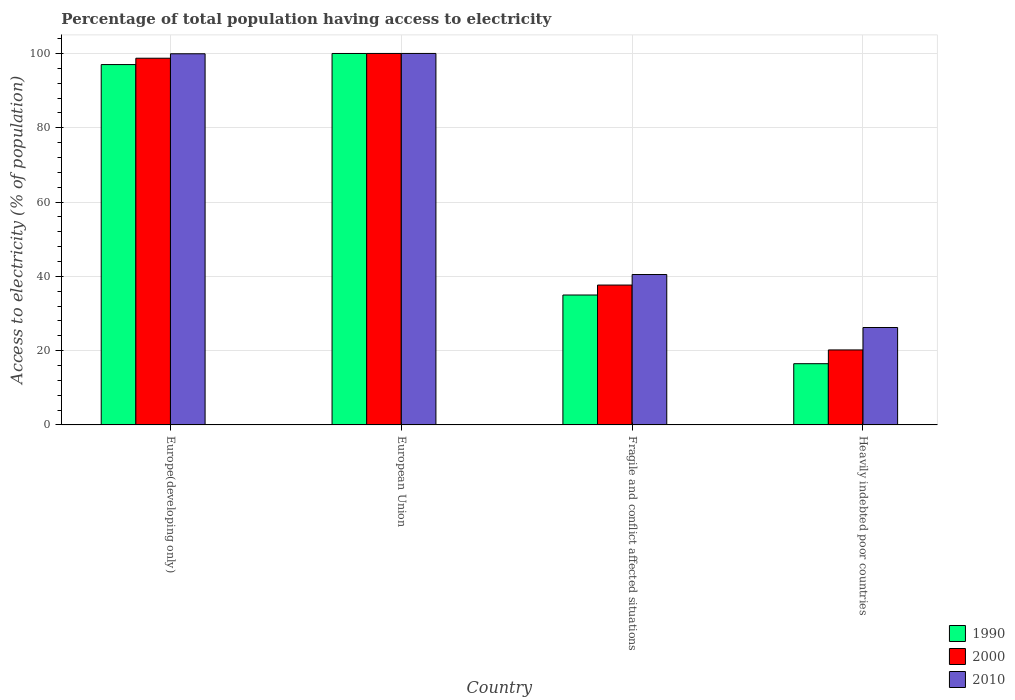How many different coloured bars are there?
Your answer should be very brief. 3. Are the number of bars per tick equal to the number of legend labels?
Your answer should be very brief. Yes. How many bars are there on the 1st tick from the right?
Offer a very short reply. 3. What is the label of the 1st group of bars from the left?
Offer a terse response. Europe(developing only). What is the percentage of population that have access to electricity in 2010 in Fragile and conflict affected situations?
Provide a short and direct response. 40.49. Across all countries, what is the minimum percentage of population that have access to electricity in 1990?
Offer a very short reply. 16.48. In which country was the percentage of population that have access to electricity in 1990 maximum?
Ensure brevity in your answer.  European Union. In which country was the percentage of population that have access to electricity in 2000 minimum?
Your response must be concise. Heavily indebted poor countries. What is the total percentage of population that have access to electricity in 2000 in the graph?
Provide a short and direct response. 256.55. What is the difference between the percentage of population that have access to electricity in 2010 in Europe(developing only) and that in European Union?
Offer a very short reply. -0.09. What is the difference between the percentage of population that have access to electricity in 2000 in Europe(developing only) and the percentage of population that have access to electricity in 1990 in Heavily indebted poor countries?
Provide a succinct answer. 82.24. What is the average percentage of population that have access to electricity in 1990 per country?
Offer a terse response. 62.11. What is the difference between the percentage of population that have access to electricity of/in 2010 and percentage of population that have access to electricity of/in 2000 in European Union?
Provide a short and direct response. 0. What is the ratio of the percentage of population that have access to electricity in 1990 in Europe(developing only) to that in European Union?
Your answer should be compact. 0.97. Is the percentage of population that have access to electricity in 2000 in European Union less than that in Heavily indebted poor countries?
Make the answer very short. No. What is the difference between the highest and the second highest percentage of population that have access to electricity in 1990?
Give a very brief answer. 62.03. What is the difference between the highest and the lowest percentage of population that have access to electricity in 2010?
Your answer should be compact. 73.78. In how many countries, is the percentage of population that have access to electricity in 1990 greater than the average percentage of population that have access to electricity in 1990 taken over all countries?
Your answer should be very brief. 2. What does the 2nd bar from the left in Heavily indebted poor countries represents?
Keep it short and to the point. 2000. Is it the case that in every country, the sum of the percentage of population that have access to electricity in 2010 and percentage of population that have access to electricity in 1990 is greater than the percentage of population that have access to electricity in 2000?
Make the answer very short. Yes. What is the difference between two consecutive major ticks on the Y-axis?
Make the answer very short. 20. Does the graph contain grids?
Your response must be concise. Yes. Where does the legend appear in the graph?
Provide a succinct answer. Bottom right. What is the title of the graph?
Make the answer very short. Percentage of total population having access to electricity. What is the label or title of the X-axis?
Offer a terse response. Country. What is the label or title of the Y-axis?
Give a very brief answer. Access to electricity (% of population). What is the Access to electricity (% of population) in 1990 in Europe(developing only)?
Your answer should be compact. 97. What is the Access to electricity (% of population) of 2000 in Europe(developing only)?
Keep it short and to the point. 98.72. What is the Access to electricity (% of population) in 2010 in Europe(developing only)?
Offer a very short reply. 99.91. What is the Access to electricity (% of population) of 1990 in European Union?
Ensure brevity in your answer.  99.99. What is the Access to electricity (% of population) of 2000 in European Union?
Make the answer very short. 100. What is the Access to electricity (% of population) of 2010 in European Union?
Provide a short and direct response. 100. What is the Access to electricity (% of population) in 1990 in Fragile and conflict affected situations?
Ensure brevity in your answer.  34.97. What is the Access to electricity (% of population) of 2000 in Fragile and conflict affected situations?
Give a very brief answer. 37.65. What is the Access to electricity (% of population) in 2010 in Fragile and conflict affected situations?
Your answer should be very brief. 40.49. What is the Access to electricity (% of population) in 1990 in Heavily indebted poor countries?
Give a very brief answer. 16.48. What is the Access to electricity (% of population) in 2000 in Heavily indebted poor countries?
Keep it short and to the point. 20.18. What is the Access to electricity (% of population) of 2010 in Heavily indebted poor countries?
Your answer should be very brief. 26.22. Across all countries, what is the maximum Access to electricity (% of population) of 1990?
Your answer should be very brief. 99.99. Across all countries, what is the maximum Access to electricity (% of population) in 2010?
Offer a very short reply. 100. Across all countries, what is the minimum Access to electricity (% of population) in 1990?
Offer a terse response. 16.48. Across all countries, what is the minimum Access to electricity (% of population) of 2000?
Your response must be concise. 20.18. Across all countries, what is the minimum Access to electricity (% of population) of 2010?
Give a very brief answer. 26.22. What is the total Access to electricity (% of population) of 1990 in the graph?
Offer a terse response. 248.45. What is the total Access to electricity (% of population) in 2000 in the graph?
Provide a short and direct response. 256.55. What is the total Access to electricity (% of population) of 2010 in the graph?
Provide a succinct answer. 266.62. What is the difference between the Access to electricity (% of population) in 1990 in Europe(developing only) and that in European Union?
Make the answer very short. -2.99. What is the difference between the Access to electricity (% of population) of 2000 in Europe(developing only) and that in European Union?
Make the answer very short. -1.28. What is the difference between the Access to electricity (% of population) in 2010 in Europe(developing only) and that in European Union?
Provide a succinct answer. -0.09. What is the difference between the Access to electricity (% of population) of 1990 in Europe(developing only) and that in Fragile and conflict affected situations?
Make the answer very short. 62.03. What is the difference between the Access to electricity (% of population) of 2000 in Europe(developing only) and that in Fragile and conflict affected situations?
Ensure brevity in your answer.  61.07. What is the difference between the Access to electricity (% of population) of 2010 in Europe(developing only) and that in Fragile and conflict affected situations?
Give a very brief answer. 59.42. What is the difference between the Access to electricity (% of population) of 1990 in Europe(developing only) and that in Heavily indebted poor countries?
Your answer should be very brief. 80.52. What is the difference between the Access to electricity (% of population) of 2000 in Europe(developing only) and that in Heavily indebted poor countries?
Ensure brevity in your answer.  78.53. What is the difference between the Access to electricity (% of population) of 2010 in Europe(developing only) and that in Heavily indebted poor countries?
Give a very brief answer. 73.69. What is the difference between the Access to electricity (% of population) in 1990 in European Union and that in Fragile and conflict affected situations?
Make the answer very short. 65.02. What is the difference between the Access to electricity (% of population) of 2000 in European Union and that in Fragile and conflict affected situations?
Provide a succinct answer. 62.35. What is the difference between the Access to electricity (% of population) in 2010 in European Union and that in Fragile and conflict affected situations?
Your response must be concise. 59.51. What is the difference between the Access to electricity (% of population) in 1990 in European Union and that in Heavily indebted poor countries?
Your answer should be compact. 83.51. What is the difference between the Access to electricity (% of population) in 2000 in European Union and that in Heavily indebted poor countries?
Keep it short and to the point. 79.82. What is the difference between the Access to electricity (% of population) of 2010 in European Union and that in Heavily indebted poor countries?
Your answer should be very brief. 73.78. What is the difference between the Access to electricity (% of population) of 1990 in Fragile and conflict affected situations and that in Heavily indebted poor countries?
Offer a very short reply. 18.49. What is the difference between the Access to electricity (% of population) in 2000 in Fragile and conflict affected situations and that in Heavily indebted poor countries?
Make the answer very short. 17.46. What is the difference between the Access to electricity (% of population) of 2010 in Fragile and conflict affected situations and that in Heavily indebted poor countries?
Offer a very short reply. 14.27. What is the difference between the Access to electricity (% of population) in 1990 in Europe(developing only) and the Access to electricity (% of population) in 2000 in European Union?
Your answer should be very brief. -3. What is the difference between the Access to electricity (% of population) in 1990 in Europe(developing only) and the Access to electricity (% of population) in 2010 in European Union?
Offer a very short reply. -3. What is the difference between the Access to electricity (% of population) in 2000 in Europe(developing only) and the Access to electricity (% of population) in 2010 in European Union?
Your response must be concise. -1.28. What is the difference between the Access to electricity (% of population) in 1990 in Europe(developing only) and the Access to electricity (% of population) in 2000 in Fragile and conflict affected situations?
Make the answer very short. 59.36. What is the difference between the Access to electricity (% of population) of 1990 in Europe(developing only) and the Access to electricity (% of population) of 2010 in Fragile and conflict affected situations?
Your answer should be very brief. 56.52. What is the difference between the Access to electricity (% of population) of 2000 in Europe(developing only) and the Access to electricity (% of population) of 2010 in Fragile and conflict affected situations?
Make the answer very short. 58.23. What is the difference between the Access to electricity (% of population) in 1990 in Europe(developing only) and the Access to electricity (% of population) in 2000 in Heavily indebted poor countries?
Your answer should be compact. 76.82. What is the difference between the Access to electricity (% of population) of 1990 in Europe(developing only) and the Access to electricity (% of population) of 2010 in Heavily indebted poor countries?
Offer a terse response. 70.78. What is the difference between the Access to electricity (% of population) in 2000 in Europe(developing only) and the Access to electricity (% of population) in 2010 in Heavily indebted poor countries?
Ensure brevity in your answer.  72.49. What is the difference between the Access to electricity (% of population) of 1990 in European Union and the Access to electricity (% of population) of 2000 in Fragile and conflict affected situations?
Offer a very short reply. 62.35. What is the difference between the Access to electricity (% of population) of 1990 in European Union and the Access to electricity (% of population) of 2010 in Fragile and conflict affected situations?
Offer a very short reply. 59.51. What is the difference between the Access to electricity (% of population) in 2000 in European Union and the Access to electricity (% of population) in 2010 in Fragile and conflict affected situations?
Give a very brief answer. 59.51. What is the difference between the Access to electricity (% of population) of 1990 in European Union and the Access to electricity (% of population) of 2000 in Heavily indebted poor countries?
Offer a terse response. 79.81. What is the difference between the Access to electricity (% of population) in 1990 in European Union and the Access to electricity (% of population) in 2010 in Heavily indebted poor countries?
Provide a succinct answer. 73.77. What is the difference between the Access to electricity (% of population) of 2000 in European Union and the Access to electricity (% of population) of 2010 in Heavily indebted poor countries?
Give a very brief answer. 73.78. What is the difference between the Access to electricity (% of population) in 1990 in Fragile and conflict affected situations and the Access to electricity (% of population) in 2000 in Heavily indebted poor countries?
Offer a very short reply. 14.79. What is the difference between the Access to electricity (% of population) of 1990 in Fragile and conflict affected situations and the Access to electricity (% of population) of 2010 in Heavily indebted poor countries?
Offer a very short reply. 8.75. What is the difference between the Access to electricity (% of population) in 2000 in Fragile and conflict affected situations and the Access to electricity (% of population) in 2010 in Heavily indebted poor countries?
Ensure brevity in your answer.  11.43. What is the average Access to electricity (% of population) in 1990 per country?
Your answer should be compact. 62.11. What is the average Access to electricity (% of population) in 2000 per country?
Your answer should be very brief. 64.14. What is the average Access to electricity (% of population) in 2010 per country?
Provide a succinct answer. 66.66. What is the difference between the Access to electricity (% of population) in 1990 and Access to electricity (% of population) in 2000 in Europe(developing only)?
Offer a very short reply. -1.71. What is the difference between the Access to electricity (% of population) in 1990 and Access to electricity (% of population) in 2010 in Europe(developing only)?
Provide a short and direct response. -2.91. What is the difference between the Access to electricity (% of population) of 2000 and Access to electricity (% of population) of 2010 in Europe(developing only)?
Ensure brevity in your answer.  -1.2. What is the difference between the Access to electricity (% of population) in 1990 and Access to electricity (% of population) in 2000 in European Union?
Make the answer very short. -0.01. What is the difference between the Access to electricity (% of population) of 1990 and Access to electricity (% of population) of 2010 in European Union?
Keep it short and to the point. -0.01. What is the difference between the Access to electricity (% of population) in 1990 and Access to electricity (% of population) in 2000 in Fragile and conflict affected situations?
Provide a short and direct response. -2.68. What is the difference between the Access to electricity (% of population) in 1990 and Access to electricity (% of population) in 2010 in Fragile and conflict affected situations?
Give a very brief answer. -5.51. What is the difference between the Access to electricity (% of population) in 2000 and Access to electricity (% of population) in 2010 in Fragile and conflict affected situations?
Your answer should be compact. -2.84. What is the difference between the Access to electricity (% of population) of 1990 and Access to electricity (% of population) of 2000 in Heavily indebted poor countries?
Provide a succinct answer. -3.7. What is the difference between the Access to electricity (% of population) in 1990 and Access to electricity (% of population) in 2010 in Heavily indebted poor countries?
Your answer should be compact. -9.74. What is the difference between the Access to electricity (% of population) of 2000 and Access to electricity (% of population) of 2010 in Heavily indebted poor countries?
Offer a terse response. -6.04. What is the ratio of the Access to electricity (% of population) in 1990 in Europe(developing only) to that in European Union?
Your answer should be very brief. 0.97. What is the ratio of the Access to electricity (% of population) of 2000 in Europe(developing only) to that in European Union?
Your response must be concise. 0.99. What is the ratio of the Access to electricity (% of population) of 2010 in Europe(developing only) to that in European Union?
Offer a very short reply. 1. What is the ratio of the Access to electricity (% of population) of 1990 in Europe(developing only) to that in Fragile and conflict affected situations?
Your answer should be very brief. 2.77. What is the ratio of the Access to electricity (% of population) in 2000 in Europe(developing only) to that in Fragile and conflict affected situations?
Your response must be concise. 2.62. What is the ratio of the Access to electricity (% of population) in 2010 in Europe(developing only) to that in Fragile and conflict affected situations?
Keep it short and to the point. 2.47. What is the ratio of the Access to electricity (% of population) of 1990 in Europe(developing only) to that in Heavily indebted poor countries?
Give a very brief answer. 5.89. What is the ratio of the Access to electricity (% of population) of 2000 in Europe(developing only) to that in Heavily indebted poor countries?
Ensure brevity in your answer.  4.89. What is the ratio of the Access to electricity (% of population) of 2010 in Europe(developing only) to that in Heavily indebted poor countries?
Offer a terse response. 3.81. What is the ratio of the Access to electricity (% of population) of 1990 in European Union to that in Fragile and conflict affected situations?
Provide a succinct answer. 2.86. What is the ratio of the Access to electricity (% of population) of 2000 in European Union to that in Fragile and conflict affected situations?
Offer a terse response. 2.66. What is the ratio of the Access to electricity (% of population) of 2010 in European Union to that in Fragile and conflict affected situations?
Ensure brevity in your answer.  2.47. What is the ratio of the Access to electricity (% of population) in 1990 in European Union to that in Heavily indebted poor countries?
Your response must be concise. 6.07. What is the ratio of the Access to electricity (% of population) in 2000 in European Union to that in Heavily indebted poor countries?
Provide a succinct answer. 4.95. What is the ratio of the Access to electricity (% of population) of 2010 in European Union to that in Heavily indebted poor countries?
Offer a very short reply. 3.81. What is the ratio of the Access to electricity (% of population) in 1990 in Fragile and conflict affected situations to that in Heavily indebted poor countries?
Your response must be concise. 2.12. What is the ratio of the Access to electricity (% of population) of 2000 in Fragile and conflict affected situations to that in Heavily indebted poor countries?
Ensure brevity in your answer.  1.87. What is the ratio of the Access to electricity (% of population) of 2010 in Fragile and conflict affected situations to that in Heavily indebted poor countries?
Give a very brief answer. 1.54. What is the difference between the highest and the second highest Access to electricity (% of population) of 1990?
Keep it short and to the point. 2.99. What is the difference between the highest and the second highest Access to electricity (% of population) in 2000?
Offer a very short reply. 1.28. What is the difference between the highest and the second highest Access to electricity (% of population) of 2010?
Offer a very short reply. 0.09. What is the difference between the highest and the lowest Access to electricity (% of population) of 1990?
Your response must be concise. 83.51. What is the difference between the highest and the lowest Access to electricity (% of population) of 2000?
Provide a succinct answer. 79.82. What is the difference between the highest and the lowest Access to electricity (% of population) of 2010?
Provide a short and direct response. 73.78. 